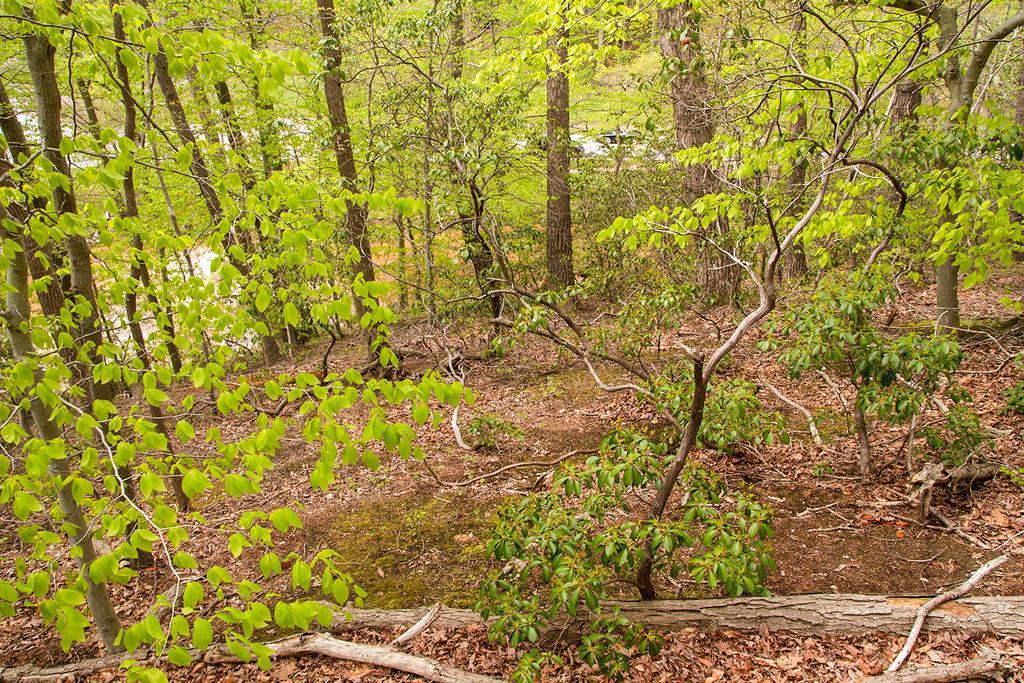In one or two sentences, can you explain what this image depicts? In this picture we can see some trees, at the bottom there is some grass and some leaves. 